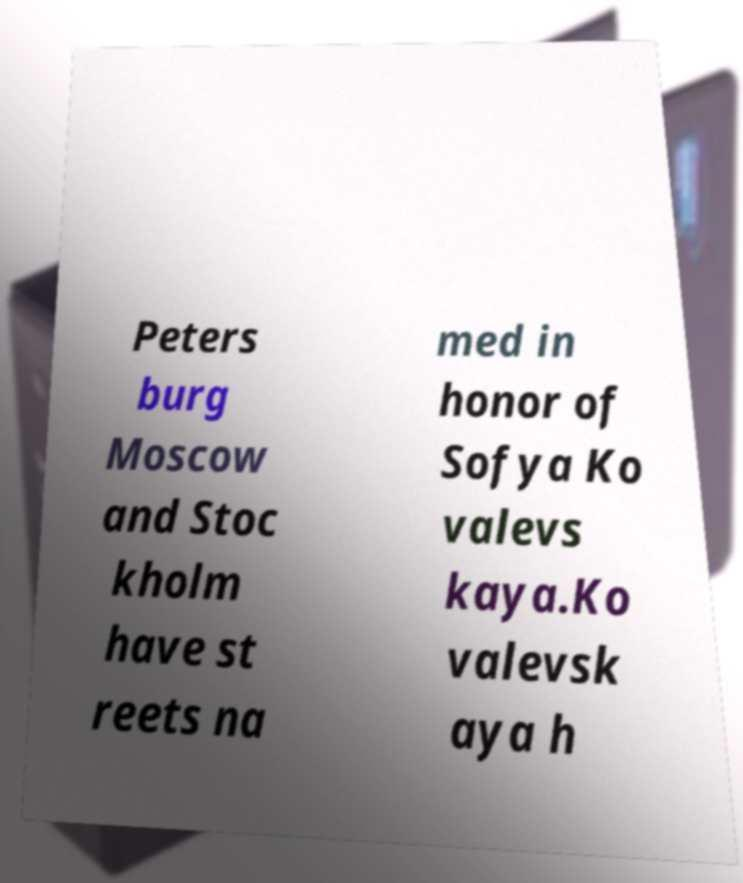Could you assist in decoding the text presented in this image and type it out clearly? Peters burg Moscow and Stoc kholm have st reets na med in honor of Sofya Ko valevs kaya.Ko valevsk aya h 